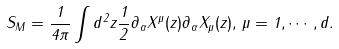<formula> <loc_0><loc_0><loc_500><loc_500>S _ { M } = \frac { 1 } { 4 \pi } \int d ^ { 2 } z \frac { 1 } { 2 } \partial _ { \alpha } X ^ { \mu } ( z ) \partial _ { \alpha } X _ { \mu } ( z ) , \, \mu = 1 , \cdots , d .</formula> 